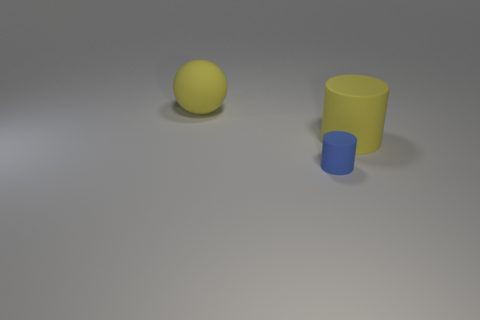Is the number of big yellow balls less than the number of tiny cyan matte things? No, there is only one big yellow ball, and it seems to be a larger version of the one tiny cyan matte object, which appears to be a small blue cylinder. 